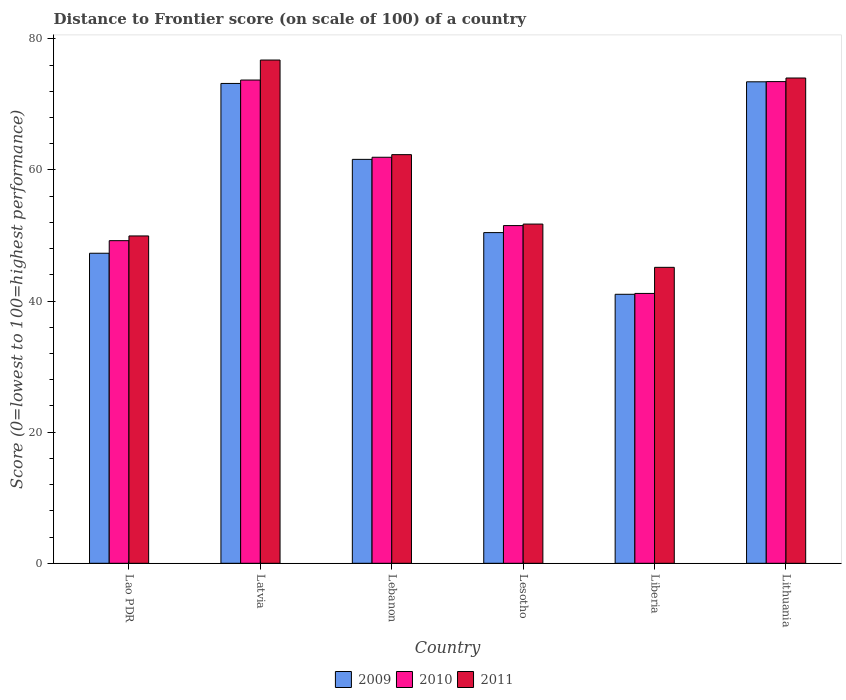How many different coloured bars are there?
Offer a terse response. 3. Are the number of bars on each tick of the X-axis equal?
Offer a very short reply. Yes. How many bars are there on the 1st tick from the right?
Your answer should be compact. 3. What is the label of the 3rd group of bars from the left?
Your answer should be very brief. Lebanon. In how many cases, is the number of bars for a given country not equal to the number of legend labels?
Provide a succinct answer. 0. What is the distance to frontier score of in 2009 in Lithuania?
Provide a succinct answer. 73.44. Across all countries, what is the maximum distance to frontier score of in 2010?
Provide a short and direct response. 73.71. Across all countries, what is the minimum distance to frontier score of in 2009?
Make the answer very short. 41.03. In which country was the distance to frontier score of in 2010 maximum?
Provide a short and direct response. Latvia. In which country was the distance to frontier score of in 2010 minimum?
Offer a terse response. Liberia. What is the total distance to frontier score of in 2009 in the graph?
Offer a very short reply. 347. What is the difference between the distance to frontier score of in 2009 in Lesotho and that in Liberia?
Your response must be concise. 9.41. What is the difference between the distance to frontier score of in 2010 in Lithuania and the distance to frontier score of in 2009 in Lao PDR?
Offer a terse response. 26.18. What is the average distance to frontier score of in 2009 per country?
Provide a succinct answer. 57.83. What is the difference between the distance to frontier score of of/in 2009 and distance to frontier score of of/in 2011 in Latvia?
Your response must be concise. -3.57. In how many countries, is the distance to frontier score of in 2009 greater than 36?
Provide a succinct answer. 6. What is the ratio of the distance to frontier score of in 2010 in Latvia to that in Liberia?
Your answer should be very brief. 1.79. Is the difference between the distance to frontier score of in 2009 in Latvia and Lebanon greater than the difference between the distance to frontier score of in 2011 in Latvia and Lebanon?
Ensure brevity in your answer.  No. What is the difference between the highest and the second highest distance to frontier score of in 2011?
Make the answer very short. -2.74. What is the difference between the highest and the lowest distance to frontier score of in 2011?
Offer a very short reply. 31.62. In how many countries, is the distance to frontier score of in 2011 greater than the average distance to frontier score of in 2011 taken over all countries?
Offer a very short reply. 3. What does the 2nd bar from the left in Liberia represents?
Your answer should be very brief. 2010. What does the 1st bar from the right in Lesotho represents?
Your answer should be compact. 2011. How many countries are there in the graph?
Your answer should be compact. 6. What is the difference between two consecutive major ticks on the Y-axis?
Offer a very short reply. 20. Where does the legend appear in the graph?
Ensure brevity in your answer.  Bottom center. What is the title of the graph?
Offer a very short reply. Distance to Frontier score (on scale of 100) of a country. What is the label or title of the X-axis?
Offer a very short reply. Country. What is the label or title of the Y-axis?
Keep it short and to the point. Score (0=lowest to 100=highest performance). What is the Score (0=lowest to 100=highest performance) of 2009 in Lao PDR?
Provide a succinct answer. 47.29. What is the Score (0=lowest to 100=highest performance) of 2010 in Lao PDR?
Your answer should be compact. 49.21. What is the Score (0=lowest to 100=highest performance) in 2011 in Lao PDR?
Your answer should be very brief. 49.93. What is the Score (0=lowest to 100=highest performance) in 2009 in Latvia?
Ensure brevity in your answer.  73.19. What is the Score (0=lowest to 100=highest performance) in 2010 in Latvia?
Your answer should be compact. 73.71. What is the Score (0=lowest to 100=highest performance) in 2011 in Latvia?
Give a very brief answer. 76.76. What is the Score (0=lowest to 100=highest performance) in 2009 in Lebanon?
Provide a short and direct response. 61.61. What is the Score (0=lowest to 100=highest performance) of 2010 in Lebanon?
Offer a very short reply. 61.93. What is the Score (0=lowest to 100=highest performance) in 2011 in Lebanon?
Offer a very short reply. 62.33. What is the Score (0=lowest to 100=highest performance) in 2009 in Lesotho?
Your answer should be compact. 50.44. What is the Score (0=lowest to 100=highest performance) of 2010 in Lesotho?
Offer a terse response. 51.51. What is the Score (0=lowest to 100=highest performance) of 2011 in Lesotho?
Your response must be concise. 51.74. What is the Score (0=lowest to 100=highest performance) in 2009 in Liberia?
Offer a terse response. 41.03. What is the Score (0=lowest to 100=highest performance) of 2010 in Liberia?
Provide a short and direct response. 41.16. What is the Score (0=lowest to 100=highest performance) in 2011 in Liberia?
Offer a terse response. 45.14. What is the Score (0=lowest to 100=highest performance) of 2009 in Lithuania?
Keep it short and to the point. 73.44. What is the Score (0=lowest to 100=highest performance) of 2010 in Lithuania?
Provide a short and direct response. 73.47. What is the Score (0=lowest to 100=highest performance) of 2011 in Lithuania?
Give a very brief answer. 74.02. Across all countries, what is the maximum Score (0=lowest to 100=highest performance) in 2009?
Provide a succinct answer. 73.44. Across all countries, what is the maximum Score (0=lowest to 100=highest performance) in 2010?
Provide a succinct answer. 73.71. Across all countries, what is the maximum Score (0=lowest to 100=highest performance) of 2011?
Your response must be concise. 76.76. Across all countries, what is the minimum Score (0=lowest to 100=highest performance) of 2009?
Offer a very short reply. 41.03. Across all countries, what is the minimum Score (0=lowest to 100=highest performance) of 2010?
Provide a succinct answer. 41.16. Across all countries, what is the minimum Score (0=lowest to 100=highest performance) in 2011?
Your answer should be compact. 45.14. What is the total Score (0=lowest to 100=highest performance) of 2009 in the graph?
Give a very brief answer. 347. What is the total Score (0=lowest to 100=highest performance) of 2010 in the graph?
Your answer should be compact. 350.99. What is the total Score (0=lowest to 100=highest performance) of 2011 in the graph?
Keep it short and to the point. 359.92. What is the difference between the Score (0=lowest to 100=highest performance) of 2009 in Lao PDR and that in Latvia?
Your answer should be very brief. -25.9. What is the difference between the Score (0=lowest to 100=highest performance) of 2010 in Lao PDR and that in Latvia?
Your answer should be very brief. -24.5. What is the difference between the Score (0=lowest to 100=highest performance) in 2011 in Lao PDR and that in Latvia?
Provide a succinct answer. -26.83. What is the difference between the Score (0=lowest to 100=highest performance) of 2009 in Lao PDR and that in Lebanon?
Keep it short and to the point. -14.32. What is the difference between the Score (0=lowest to 100=highest performance) of 2010 in Lao PDR and that in Lebanon?
Your answer should be very brief. -12.72. What is the difference between the Score (0=lowest to 100=highest performance) of 2011 in Lao PDR and that in Lebanon?
Offer a terse response. -12.4. What is the difference between the Score (0=lowest to 100=highest performance) in 2009 in Lao PDR and that in Lesotho?
Provide a succinct answer. -3.15. What is the difference between the Score (0=lowest to 100=highest performance) in 2010 in Lao PDR and that in Lesotho?
Your answer should be compact. -2.3. What is the difference between the Score (0=lowest to 100=highest performance) in 2011 in Lao PDR and that in Lesotho?
Offer a very short reply. -1.81. What is the difference between the Score (0=lowest to 100=highest performance) of 2009 in Lao PDR and that in Liberia?
Provide a short and direct response. 6.26. What is the difference between the Score (0=lowest to 100=highest performance) in 2010 in Lao PDR and that in Liberia?
Your answer should be very brief. 8.05. What is the difference between the Score (0=lowest to 100=highest performance) of 2011 in Lao PDR and that in Liberia?
Ensure brevity in your answer.  4.79. What is the difference between the Score (0=lowest to 100=highest performance) of 2009 in Lao PDR and that in Lithuania?
Your answer should be very brief. -26.15. What is the difference between the Score (0=lowest to 100=highest performance) of 2010 in Lao PDR and that in Lithuania?
Offer a terse response. -24.26. What is the difference between the Score (0=lowest to 100=highest performance) of 2011 in Lao PDR and that in Lithuania?
Your answer should be compact. -24.09. What is the difference between the Score (0=lowest to 100=highest performance) in 2009 in Latvia and that in Lebanon?
Offer a terse response. 11.58. What is the difference between the Score (0=lowest to 100=highest performance) in 2010 in Latvia and that in Lebanon?
Offer a very short reply. 11.78. What is the difference between the Score (0=lowest to 100=highest performance) of 2011 in Latvia and that in Lebanon?
Offer a very short reply. 14.43. What is the difference between the Score (0=lowest to 100=highest performance) of 2009 in Latvia and that in Lesotho?
Ensure brevity in your answer.  22.75. What is the difference between the Score (0=lowest to 100=highest performance) of 2011 in Latvia and that in Lesotho?
Your answer should be very brief. 25.02. What is the difference between the Score (0=lowest to 100=highest performance) of 2009 in Latvia and that in Liberia?
Your answer should be compact. 32.16. What is the difference between the Score (0=lowest to 100=highest performance) in 2010 in Latvia and that in Liberia?
Ensure brevity in your answer.  32.55. What is the difference between the Score (0=lowest to 100=highest performance) in 2011 in Latvia and that in Liberia?
Offer a terse response. 31.62. What is the difference between the Score (0=lowest to 100=highest performance) of 2009 in Latvia and that in Lithuania?
Your answer should be very brief. -0.25. What is the difference between the Score (0=lowest to 100=highest performance) in 2010 in Latvia and that in Lithuania?
Keep it short and to the point. 0.24. What is the difference between the Score (0=lowest to 100=highest performance) of 2011 in Latvia and that in Lithuania?
Offer a terse response. 2.74. What is the difference between the Score (0=lowest to 100=highest performance) in 2009 in Lebanon and that in Lesotho?
Your response must be concise. 11.17. What is the difference between the Score (0=lowest to 100=highest performance) in 2010 in Lebanon and that in Lesotho?
Make the answer very short. 10.42. What is the difference between the Score (0=lowest to 100=highest performance) in 2011 in Lebanon and that in Lesotho?
Keep it short and to the point. 10.59. What is the difference between the Score (0=lowest to 100=highest performance) of 2009 in Lebanon and that in Liberia?
Give a very brief answer. 20.58. What is the difference between the Score (0=lowest to 100=highest performance) of 2010 in Lebanon and that in Liberia?
Give a very brief answer. 20.77. What is the difference between the Score (0=lowest to 100=highest performance) of 2011 in Lebanon and that in Liberia?
Make the answer very short. 17.19. What is the difference between the Score (0=lowest to 100=highest performance) in 2009 in Lebanon and that in Lithuania?
Make the answer very short. -11.83. What is the difference between the Score (0=lowest to 100=highest performance) in 2010 in Lebanon and that in Lithuania?
Provide a succinct answer. -11.54. What is the difference between the Score (0=lowest to 100=highest performance) in 2011 in Lebanon and that in Lithuania?
Offer a terse response. -11.69. What is the difference between the Score (0=lowest to 100=highest performance) of 2009 in Lesotho and that in Liberia?
Your answer should be compact. 9.41. What is the difference between the Score (0=lowest to 100=highest performance) in 2010 in Lesotho and that in Liberia?
Ensure brevity in your answer.  10.35. What is the difference between the Score (0=lowest to 100=highest performance) of 2009 in Lesotho and that in Lithuania?
Your answer should be compact. -23. What is the difference between the Score (0=lowest to 100=highest performance) of 2010 in Lesotho and that in Lithuania?
Ensure brevity in your answer.  -21.96. What is the difference between the Score (0=lowest to 100=highest performance) of 2011 in Lesotho and that in Lithuania?
Ensure brevity in your answer.  -22.28. What is the difference between the Score (0=lowest to 100=highest performance) in 2009 in Liberia and that in Lithuania?
Your response must be concise. -32.41. What is the difference between the Score (0=lowest to 100=highest performance) in 2010 in Liberia and that in Lithuania?
Your answer should be very brief. -32.31. What is the difference between the Score (0=lowest to 100=highest performance) in 2011 in Liberia and that in Lithuania?
Offer a very short reply. -28.88. What is the difference between the Score (0=lowest to 100=highest performance) in 2009 in Lao PDR and the Score (0=lowest to 100=highest performance) in 2010 in Latvia?
Keep it short and to the point. -26.42. What is the difference between the Score (0=lowest to 100=highest performance) of 2009 in Lao PDR and the Score (0=lowest to 100=highest performance) of 2011 in Latvia?
Ensure brevity in your answer.  -29.47. What is the difference between the Score (0=lowest to 100=highest performance) of 2010 in Lao PDR and the Score (0=lowest to 100=highest performance) of 2011 in Latvia?
Offer a very short reply. -27.55. What is the difference between the Score (0=lowest to 100=highest performance) of 2009 in Lao PDR and the Score (0=lowest to 100=highest performance) of 2010 in Lebanon?
Offer a terse response. -14.64. What is the difference between the Score (0=lowest to 100=highest performance) in 2009 in Lao PDR and the Score (0=lowest to 100=highest performance) in 2011 in Lebanon?
Your answer should be very brief. -15.04. What is the difference between the Score (0=lowest to 100=highest performance) of 2010 in Lao PDR and the Score (0=lowest to 100=highest performance) of 2011 in Lebanon?
Your answer should be compact. -13.12. What is the difference between the Score (0=lowest to 100=highest performance) of 2009 in Lao PDR and the Score (0=lowest to 100=highest performance) of 2010 in Lesotho?
Offer a very short reply. -4.22. What is the difference between the Score (0=lowest to 100=highest performance) in 2009 in Lao PDR and the Score (0=lowest to 100=highest performance) in 2011 in Lesotho?
Provide a succinct answer. -4.45. What is the difference between the Score (0=lowest to 100=highest performance) in 2010 in Lao PDR and the Score (0=lowest to 100=highest performance) in 2011 in Lesotho?
Offer a terse response. -2.53. What is the difference between the Score (0=lowest to 100=highest performance) of 2009 in Lao PDR and the Score (0=lowest to 100=highest performance) of 2010 in Liberia?
Provide a short and direct response. 6.13. What is the difference between the Score (0=lowest to 100=highest performance) of 2009 in Lao PDR and the Score (0=lowest to 100=highest performance) of 2011 in Liberia?
Keep it short and to the point. 2.15. What is the difference between the Score (0=lowest to 100=highest performance) in 2010 in Lao PDR and the Score (0=lowest to 100=highest performance) in 2011 in Liberia?
Provide a short and direct response. 4.07. What is the difference between the Score (0=lowest to 100=highest performance) in 2009 in Lao PDR and the Score (0=lowest to 100=highest performance) in 2010 in Lithuania?
Provide a succinct answer. -26.18. What is the difference between the Score (0=lowest to 100=highest performance) of 2009 in Lao PDR and the Score (0=lowest to 100=highest performance) of 2011 in Lithuania?
Give a very brief answer. -26.73. What is the difference between the Score (0=lowest to 100=highest performance) of 2010 in Lao PDR and the Score (0=lowest to 100=highest performance) of 2011 in Lithuania?
Provide a short and direct response. -24.81. What is the difference between the Score (0=lowest to 100=highest performance) in 2009 in Latvia and the Score (0=lowest to 100=highest performance) in 2010 in Lebanon?
Offer a very short reply. 11.26. What is the difference between the Score (0=lowest to 100=highest performance) of 2009 in Latvia and the Score (0=lowest to 100=highest performance) of 2011 in Lebanon?
Provide a short and direct response. 10.86. What is the difference between the Score (0=lowest to 100=highest performance) of 2010 in Latvia and the Score (0=lowest to 100=highest performance) of 2011 in Lebanon?
Make the answer very short. 11.38. What is the difference between the Score (0=lowest to 100=highest performance) in 2009 in Latvia and the Score (0=lowest to 100=highest performance) in 2010 in Lesotho?
Ensure brevity in your answer.  21.68. What is the difference between the Score (0=lowest to 100=highest performance) in 2009 in Latvia and the Score (0=lowest to 100=highest performance) in 2011 in Lesotho?
Offer a very short reply. 21.45. What is the difference between the Score (0=lowest to 100=highest performance) of 2010 in Latvia and the Score (0=lowest to 100=highest performance) of 2011 in Lesotho?
Give a very brief answer. 21.97. What is the difference between the Score (0=lowest to 100=highest performance) of 2009 in Latvia and the Score (0=lowest to 100=highest performance) of 2010 in Liberia?
Your answer should be very brief. 32.03. What is the difference between the Score (0=lowest to 100=highest performance) in 2009 in Latvia and the Score (0=lowest to 100=highest performance) in 2011 in Liberia?
Offer a very short reply. 28.05. What is the difference between the Score (0=lowest to 100=highest performance) in 2010 in Latvia and the Score (0=lowest to 100=highest performance) in 2011 in Liberia?
Provide a succinct answer. 28.57. What is the difference between the Score (0=lowest to 100=highest performance) of 2009 in Latvia and the Score (0=lowest to 100=highest performance) of 2010 in Lithuania?
Give a very brief answer. -0.28. What is the difference between the Score (0=lowest to 100=highest performance) of 2009 in Latvia and the Score (0=lowest to 100=highest performance) of 2011 in Lithuania?
Ensure brevity in your answer.  -0.83. What is the difference between the Score (0=lowest to 100=highest performance) in 2010 in Latvia and the Score (0=lowest to 100=highest performance) in 2011 in Lithuania?
Give a very brief answer. -0.31. What is the difference between the Score (0=lowest to 100=highest performance) in 2009 in Lebanon and the Score (0=lowest to 100=highest performance) in 2011 in Lesotho?
Provide a short and direct response. 9.87. What is the difference between the Score (0=lowest to 100=highest performance) of 2010 in Lebanon and the Score (0=lowest to 100=highest performance) of 2011 in Lesotho?
Offer a terse response. 10.19. What is the difference between the Score (0=lowest to 100=highest performance) of 2009 in Lebanon and the Score (0=lowest to 100=highest performance) of 2010 in Liberia?
Offer a very short reply. 20.45. What is the difference between the Score (0=lowest to 100=highest performance) in 2009 in Lebanon and the Score (0=lowest to 100=highest performance) in 2011 in Liberia?
Offer a terse response. 16.47. What is the difference between the Score (0=lowest to 100=highest performance) of 2010 in Lebanon and the Score (0=lowest to 100=highest performance) of 2011 in Liberia?
Ensure brevity in your answer.  16.79. What is the difference between the Score (0=lowest to 100=highest performance) of 2009 in Lebanon and the Score (0=lowest to 100=highest performance) of 2010 in Lithuania?
Your response must be concise. -11.86. What is the difference between the Score (0=lowest to 100=highest performance) in 2009 in Lebanon and the Score (0=lowest to 100=highest performance) in 2011 in Lithuania?
Your answer should be compact. -12.41. What is the difference between the Score (0=lowest to 100=highest performance) of 2010 in Lebanon and the Score (0=lowest to 100=highest performance) of 2011 in Lithuania?
Your answer should be compact. -12.09. What is the difference between the Score (0=lowest to 100=highest performance) in 2009 in Lesotho and the Score (0=lowest to 100=highest performance) in 2010 in Liberia?
Your response must be concise. 9.28. What is the difference between the Score (0=lowest to 100=highest performance) of 2009 in Lesotho and the Score (0=lowest to 100=highest performance) of 2011 in Liberia?
Keep it short and to the point. 5.3. What is the difference between the Score (0=lowest to 100=highest performance) of 2010 in Lesotho and the Score (0=lowest to 100=highest performance) of 2011 in Liberia?
Your answer should be very brief. 6.37. What is the difference between the Score (0=lowest to 100=highest performance) in 2009 in Lesotho and the Score (0=lowest to 100=highest performance) in 2010 in Lithuania?
Provide a short and direct response. -23.03. What is the difference between the Score (0=lowest to 100=highest performance) in 2009 in Lesotho and the Score (0=lowest to 100=highest performance) in 2011 in Lithuania?
Your response must be concise. -23.58. What is the difference between the Score (0=lowest to 100=highest performance) of 2010 in Lesotho and the Score (0=lowest to 100=highest performance) of 2011 in Lithuania?
Offer a terse response. -22.51. What is the difference between the Score (0=lowest to 100=highest performance) of 2009 in Liberia and the Score (0=lowest to 100=highest performance) of 2010 in Lithuania?
Offer a very short reply. -32.44. What is the difference between the Score (0=lowest to 100=highest performance) of 2009 in Liberia and the Score (0=lowest to 100=highest performance) of 2011 in Lithuania?
Keep it short and to the point. -32.99. What is the difference between the Score (0=lowest to 100=highest performance) in 2010 in Liberia and the Score (0=lowest to 100=highest performance) in 2011 in Lithuania?
Offer a terse response. -32.86. What is the average Score (0=lowest to 100=highest performance) of 2009 per country?
Make the answer very short. 57.83. What is the average Score (0=lowest to 100=highest performance) of 2010 per country?
Ensure brevity in your answer.  58.5. What is the average Score (0=lowest to 100=highest performance) in 2011 per country?
Your answer should be very brief. 59.99. What is the difference between the Score (0=lowest to 100=highest performance) of 2009 and Score (0=lowest to 100=highest performance) of 2010 in Lao PDR?
Your answer should be compact. -1.92. What is the difference between the Score (0=lowest to 100=highest performance) of 2009 and Score (0=lowest to 100=highest performance) of 2011 in Lao PDR?
Give a very brief answer. -2.64. What is the difference between the Score (0=lowest to 100=highest performance) in 2010 and Score (0=lowest to 100=highest performance) in 2011 in Lao PDR?
Give a very brief answer. -0.72. What is the difference between the Score (0=lowest to 100=highest performance) of 2009 and Score (0=lowest to 100=highest performance) of 2010 in Latvia?
Your response must be concise. -0.52. What is the difference between the Score (0=lowest to 100=highest performance) in 2009 and Score (0=lowest to 100=highest performance) in 2011 in Latvia?
Offer a terse response. -3.57. What is the difference between the Score (0=lowest to 100=highest performance) of 2010 and Score (0=lowest to 100=highest performance) of 2011 in Latvia?
Your answer should be very brief. -3.05. What is the difference between the Score (0=lowest to 100=highest performance) of 2009 and Score (0=lowest to 100=highest performance) of 2010 in Lebanon?
Keep it short and to the point. -0.32. What is the difference between the Score (0=lowest to 100=highest performance) of 2009 and Score (0=lowest to 100=highest performance) of 2011 in Lebanon?
Keep it short and to the point. -0.72. What is the difference between the Score (0=lowest to 100=highest performance) of 2010 and Score (0=lowest to 100=highest performance) of 2011 in Lebanon?
Keep it short and to the point. -0.4. What is the difference between the Score (0=lowest to 100=highest performance) in 2009 and Score (0=lowest to 100=highest performance) in 2010 in Lesotho?
Provide a short and direct response. -1.07. What is the difference between the Score (0=lowest to 100=highest performance) of 2010 and Score (0=lowest to 100=highest performance) of 2011 in Lesotho?
Make the answer very short. -0.23. What is the difference between the Score (0=lowest to 100=highest performance) of 2009 and Score (0=lowest to 100=highest performance) of 2010 in Liberia?
Your response must be concise. -0.13. What is the difference between the Score (0=lowest to 100=highest performance) in 2009 and Score (0=lowest to 100=highest performance) in 2011 in Liberia?
Ensure brevity in your answer.  -4.11. What is the difference between the Score (0=lowest to 100=highest performance) of 2010 and Score (0=lowest to 100=highest performance) of 2011 in Liberia?
Provide a short and direct response. -3.98. What is the difference between the Score (0=lowest to 100=highest performance) of 2009 and Score (0=lowest to 100=highest performance) of 2010 in Lithuania?
Your response must be concise. -0.03. What is the difference between the Score (0=lowest to 100=highest performance) of 2009 and Score (0=lowest to 100=highest performance) of 2011 in Lithuania?
Your response must be concise. -0.58. What is the difference between the Score (0=lowest to 100=highest performance) in 2010 and Score (0=lowest to 100=highest performance) in 2011 in Lithuania?
Your answer should be compact. -0.55. What is the ratio of the Score (0=lowest to 100=highest performance) of 2009 in Lao PDR to that in Latvia?
Your answer should be very brief. 0.65. What is the ratio of the Score (0=lowest to 100=highest performance) of 2010 in Lao PDR to that in Latvia?
Your answer should be very brief. 0.67. What is the ratio of the Score (0=lowest to 100=highest performance) of 2011 in Lao PDR to that in Latvia?
Your response must be concise. 0.65. What is the ratio of the Score (0=lowest to 100=highest performance) in 2009 in Lao PDR to that in Lebanon?
Your answer should be compact. 0.77. What is the ratio of the Score (0=lowest to 100=highest performance) of 2010 in Lao PDR to that in Lebanon?
Provide a succinct answer. 0.79. What is the ratio of the Score (0=lowest to 100=highest performance) in 2011 in Lao PDR to that in Lebanon?
Provide a short and direct response. 0.8. What is the ratio of the Score (0=lowest to 100=highest performance) in 2010 in Lao PDR to that in Lesotho?
Make the answer very short. 0.96. What is the ratio of the Score (0=lowest to 100=highest performance) in 2011 in Lao PDR to that in Lesotho?
Keep it short and to the point. 0.96. What is the ratio of the Score (0=lowest to 100=highest performance) of 2009 in Lao PDR to that in Liberia?
Ensure brevity in your answer.  1.15. What is the ratio of the Score (0=lowest to 100=highest performance) in 2010 in Lao PDR to that in Liberia?
Keep it short and to the point. 1.2. What is the ratio of the Score (0=lowest to 100=highest performance) of 2011 in Lao PDR to that in Liberia?
Offer a terse response. 1.11. What is the ratio of the Score (0=lowest to 100=highest performance) in 2009 in Lao PDR to that in Lithuania?
Your answer should be compact. 0.64. What is the ratio of the Score (0=lowest to 100=highest performance) of 2010 in Lao PDR to that in Lithuania?
Provide a short and direct response. 0.67. What is the ratio of the Score (0=lowest to 100=highest performance) of 2011 in Lao PDR to that in Lithuania?
Your response must be concise. 0.67. What is the ratio of the Score (0=lowest to 100=highest performance) in 2009 in Latvia to that in Lebanon?
Give a very brief answer. 1.19. What is the ratio of the Score (0=lowest to 100=highest performance) of 2010 in Latvia to that in Lebanon?
Ensure brevity in your answer.  1.19. What is the ratio of the Score (0=lowest to 100=highest performance) in 2011 in Latvia to that in Lebanon?
Keep it short and to the point. 1.23. What is the ratio of the Score (0=lowest to 100=highest performance) in 2009 in Latvia to that in Lesotho?
Provide a succinct answer. 1.45. What is the ratio of the Score (0=lowest to 100=highest performance) of 2010 in Latvia to that in Lesotho?
Offer a very short reply. 1.43. What is the ratio of the Score (0=lowest to 100=highest performance) of 2011 in Latvia to that in Lesotho?
Your answer should be compact. 1.48. What is the ratio of the Score (0=lowest to 100=highest performance) in 2009 in Latvia to that in Liberia?
Your answer should be compact. 1.78. What is the ratio of the Score (0=lowest to 100=highest performance) of 2010 in Latvia to that in Liberia?
Give a very brief answer. 1.79. What is the ratio of the Score (0=lowest to 100=highest performance) in 2011 in Latvia to that in Liberia?
Give a very brief answer. 1.7. What is the ratio of the Score (0=lowest to 100=highest performance) of 2009 in Latvia to that in Lithuania?
Give a very brief answer. 1. What is the ratio of the Score (0=lowest to 100=highest performance) of 2010 in Latvia to that in Lithuania?
Your answer should be very brief. 1. What is the ratio of the Score (0=lowest to 100=highest performance) of 2011 in Latvia to that in Lithuania?
Your answer should be very brief. 1.04. What is the ratio of the Score (0=lowest to 100=highest performance) in 2009 in Lebanon to that in Lesotho?
Give a very brief answer. 1.22. What is the ratio of the Score (0=lowest to 100=highest performance) of 2010 in Lebanon to that in Lesotho?
Provide a short and direct response. 1.2. What is the ratio of the Score (0=lowest to 100=highest performance) in 2011 in Lebanon to that in Lesotho?
Offer a terse response. 1.2. What is the ratio of the Score (0=lowest to 100=highest performance) of 2009 in Lebanon to that in Liberia?
Provide a succinct answer. 1.5. What is the ratio of the Score (0=lowest to 100=highest performance) of 2010 in Lebanon to that in Liberia?
Ensure brevity in your answer.  1.5. What is the ratio of the Score (0=lowest to 100=highest performance) of 2011 in Lebanon to that in Liberia?
Keep it short and to the point. 1.38. What is the ratio of the Score (0=lowest to 100=highest performance) of 2009 in Lebanon to that in Lithuania?
Your answer should be compact. 0.84. What is the ratio of the Score (0=lowest to 100=highest performance) in 2010 in Lebanon to that in Lithuania?
Give a very brief answer. 0.84. What is the ratio of the Score (0=lowest to 100=highest performance) of 2011 in Lebanon to that in Lithuania?
Make the answer very short. 0.84. What is the ratio of the Score (0=lowest to 100=highest performance) in 2009 in Lesotho to that in Liberia?
Provide a short and direct response. 1.23. What is the ratio of the Score (0=lowest to 100=highest performance) of 2010 in Lesotho to that in Liberia?
Give a very brief answer. 1.25. What is the ratio of the Score (0=lowest to 100=highest performance) of 2011 in Lesotho to that in Liberia?
Provide a succinct answer. 1.15. What is the ratio of the Score (0=lowest to 100=highest performance) of 2009 in Lesotho to that in Lithuania?
Your answer should be compact. 0.69. What is the ratio of the Score (0=lowest to 100=highest performance) of 2010 in Lesotho to that in Lithuania?
Your response must be concise. 0.7. What is the ratio of the Score (0=lowest to 100=highest performance) of 2011 in Lesotho to that in Lithuania?
Provide a succinct answer. 0.7. What is the ratio of the Score (0=lowest to 100=highest performance) of 2009 in Liberia to that in Lithuania?
Your answer should be very brief. 0.56. What is the ratio of the Score (0=lowest to 100=highest performance) of 2010 in Liberia to that in Lithuania?
Your answer should be compact. 0.56. What is the ratio of the Score (0=lowest to 100=highest performance) in 2011 in Liberia to that in Lithuania?
Provide a short and direct response. 0.61. What is the difference between the highest and the second highest Score (0=lowest to 100=highest performance) of 2010?
Your response must be concise. 0.24. What is the difference between the highest and the second highest Score (0=lowest to 100=highest performance) of 2011?
Offer a terse response. 2.74. What is the difference between the highest and the lowest Score (0=lowest to 100=highest performance) of 2009?
Offer a very short reply. 32.41. What is the difference between the highest and the lowest Score (0=lowest to 100=highest performance) of 2010?
Your answer should be compact. 32.55. What is the difference between the highest and the lowest Score (0=lowest to 100=highest performance) in 2011?
Make the answer very short. 31.62. 